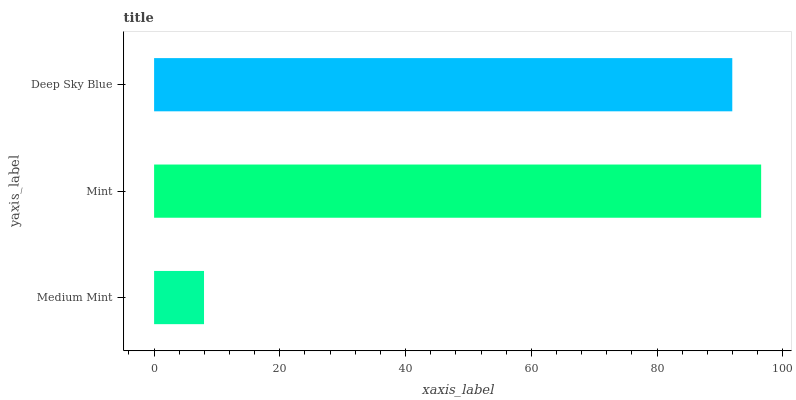Is Medium Mint the minimum?
Answer yes or no. Yes. Is Mint the maximum?
Answer yes or no. Yes. Is Deep Sky Blue the minimum?
Answer yes or no. No. Is Deep Sky Blue the maximum?
Answer yes or no. No. Is Mint greater than Deep Sky Blue?
Answer yes or no. Yes. Is Deep Sky Blue less than Mint?
Answer yes or no. Yes. Is Deep Sky Blue greater than Mint?
Answer yes or no. No. Is Mint less than Deep Sky Blue?
Answer yes or no. No. Is Deep Sky Blue the high median?
Answer yes or no. Yes. Is Deep Sky Blue the low median?
Answer yes or no. Yes. Is Medium Mint the high median?
Answer yes or no. No. Is Mint the low median?
Answer yes or no. No. 